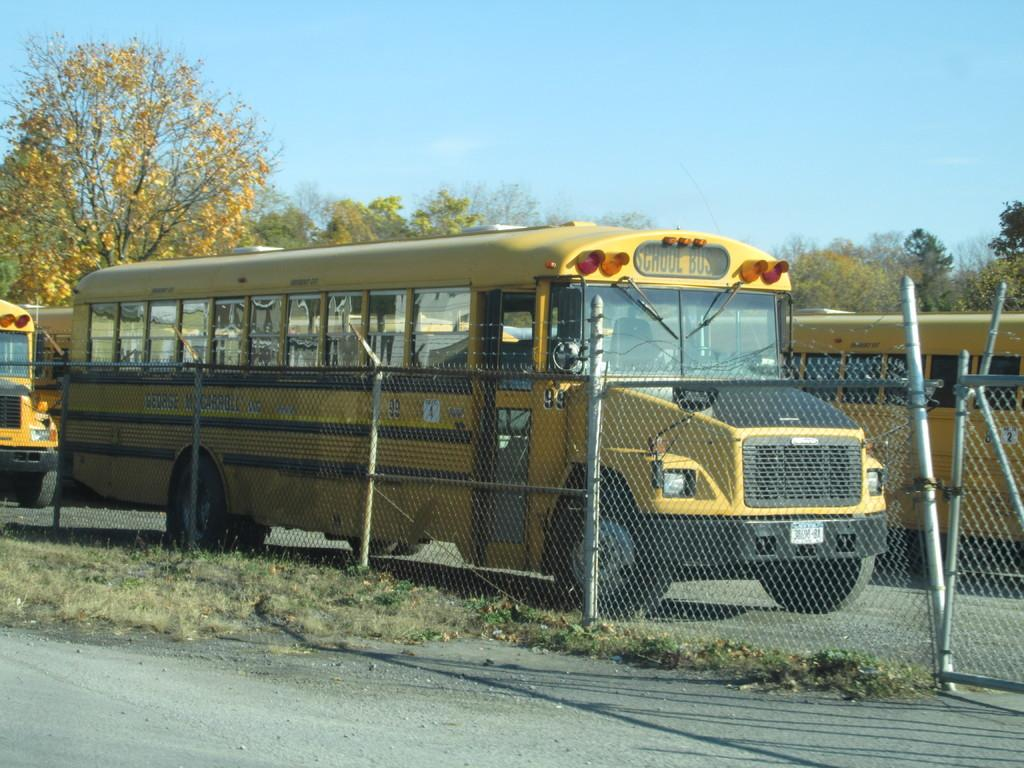<image>
Give a short and clear explanation of the subsequent image. A black and yellow School Bus behind a wire-link fence. 